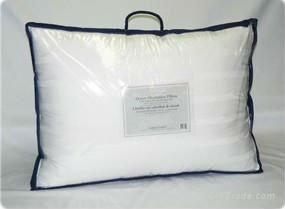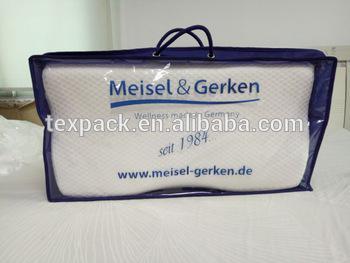The first image is the image on the left, the second image is the image on the right. For the images shown, is this caption "Each image shows a bag that holds a pillow, at least one bag is transparent, and the bag on the right has double handles." true? Answer yes or no. Yes. The first image is the image on the left, the second image is the image on the right. For the images displayed, is the sentence "There are 2 white pillows in bags with handles." factually correct? Answer yes or no. Yes. 